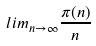<formula> <loc_0><loc_0><loc_500><loc_500>l i m _ { n \rightarrow \infty } \frac { \pi ( n ) } { n }</formula> 